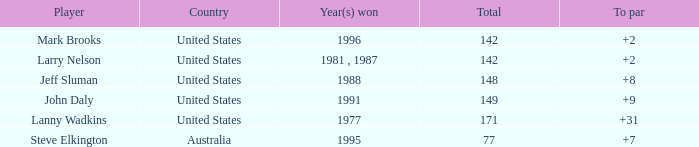Name the Total of australia and a To par smaller than 7? None. 